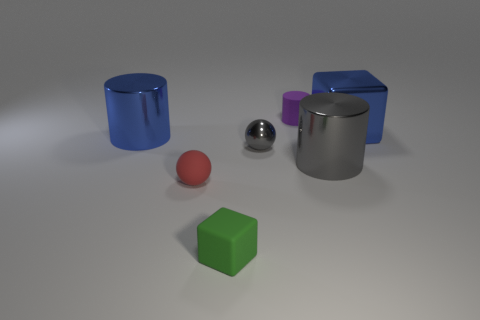Add 2 spheres. How many objects exist? 9 Subtract all cubes. How many objects are left? 5 Subtract all gray cubes. Subtract all tiny metallic things. How many objects are left? 6 Add 2 big gray objects. How many big gray objects are left? 3 Add 4 big purple things. How many big purple things exist? 4 Subtract 0 cyan cubes. How many objects are left? 7 